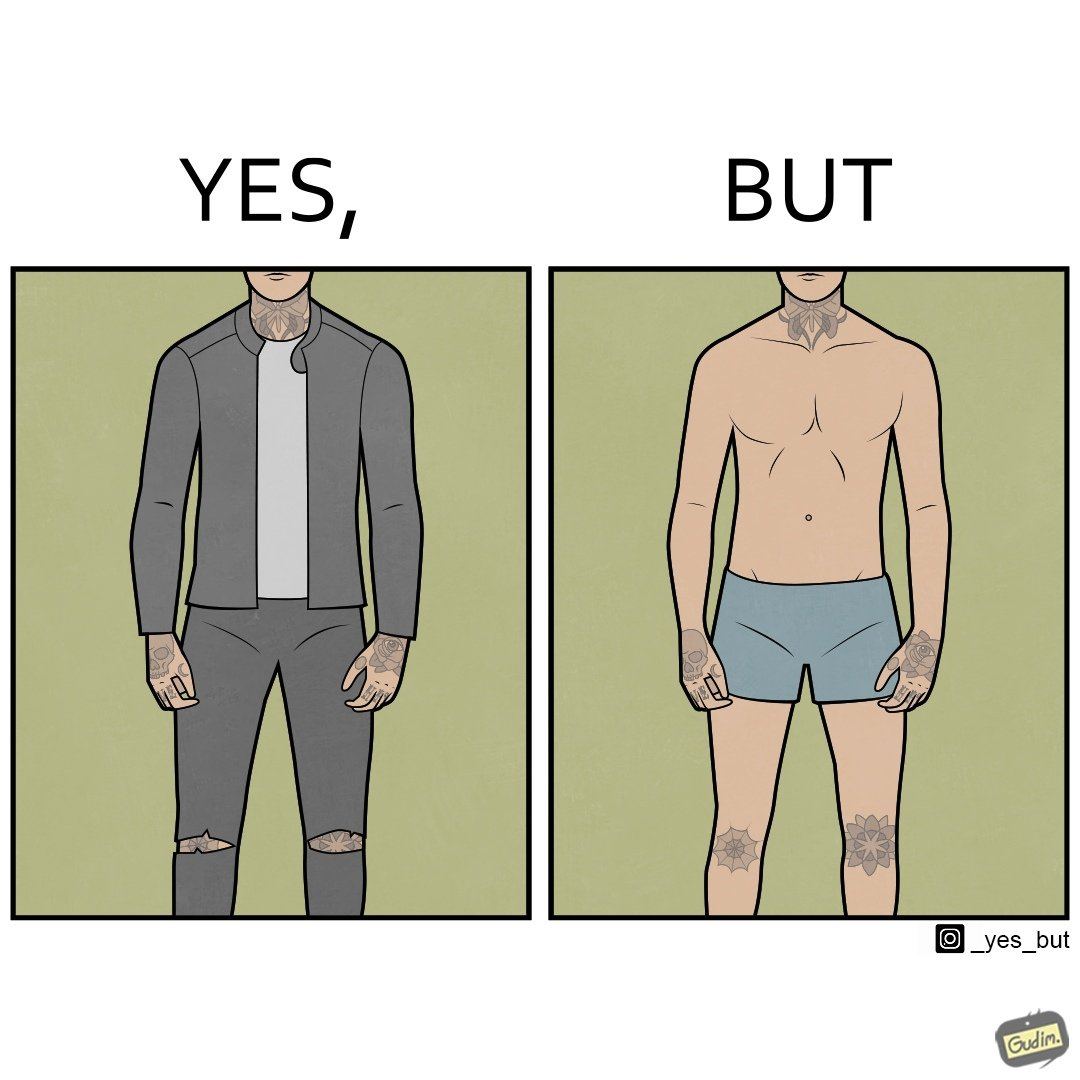What do you see in each half of this image? In the left part of the image: It is a man with tattoos on his body In the right part of the image: It is a man in his underwear with tattoos on his knees, neck and hands only 